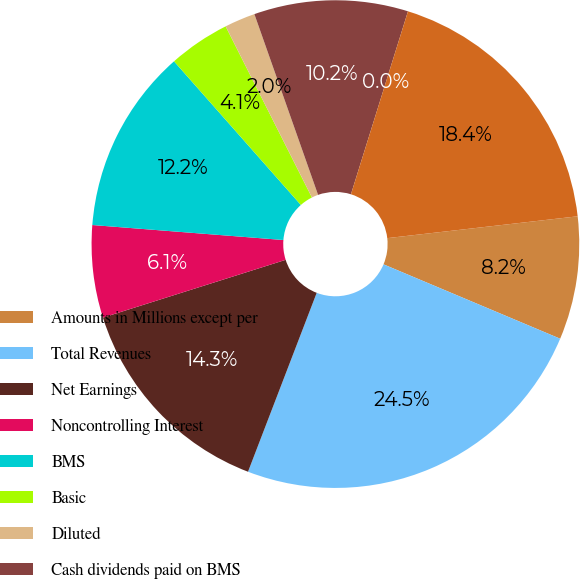Convert chart. <chart><loc_0><loc_0><loc_500><loc_500><pie_chart><fcel>Amounts in Millions except per<fcel>Total Revenues<fcel>Net Earnings<fcel>Noncontrolling Interest<fcel>BMS<fcel>Basic<fcel>Diluted<fcel>Cash dividends paid on BMS<fcel>Cash dividends declared per<fcel>Cash and cash equivalents<nl><fcel>8.16%<fcel>24.49%<fcel>14.29%<fcel>6.12%<fcel>12.24%<fcel>4.08%<fcel>2.04%<fcel>10.2%<fcel>0.0%<fcel>18.37%<nl></chart> 